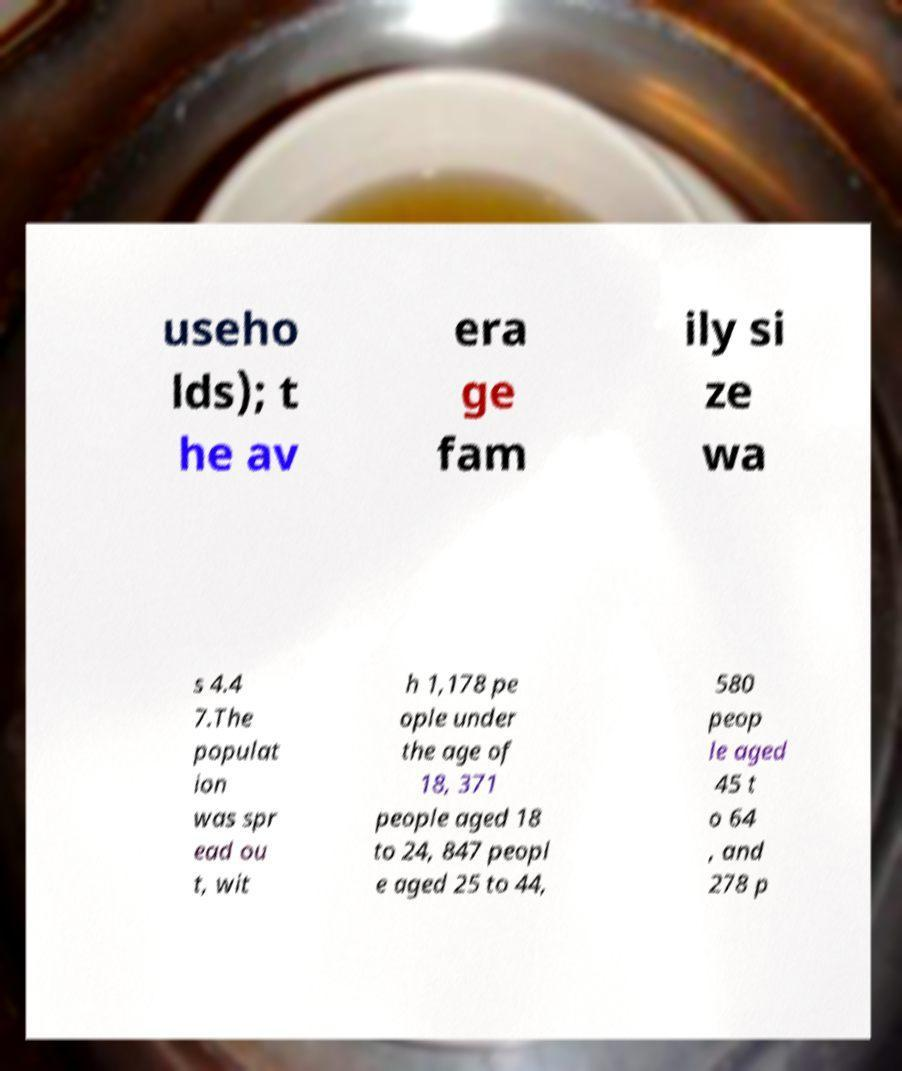Could you extract and type out the text from this image? useho lds); t he av era ge fam ily si ze wa s 4.4 7.The populat ion was spr ead ou t, wit h 1,178 pe ople under the age of 18, 371 people aged 18 to 24, 847 peopl e aged 25 to 44, 580 peop le aged 45 t o 64 , and 278 p 